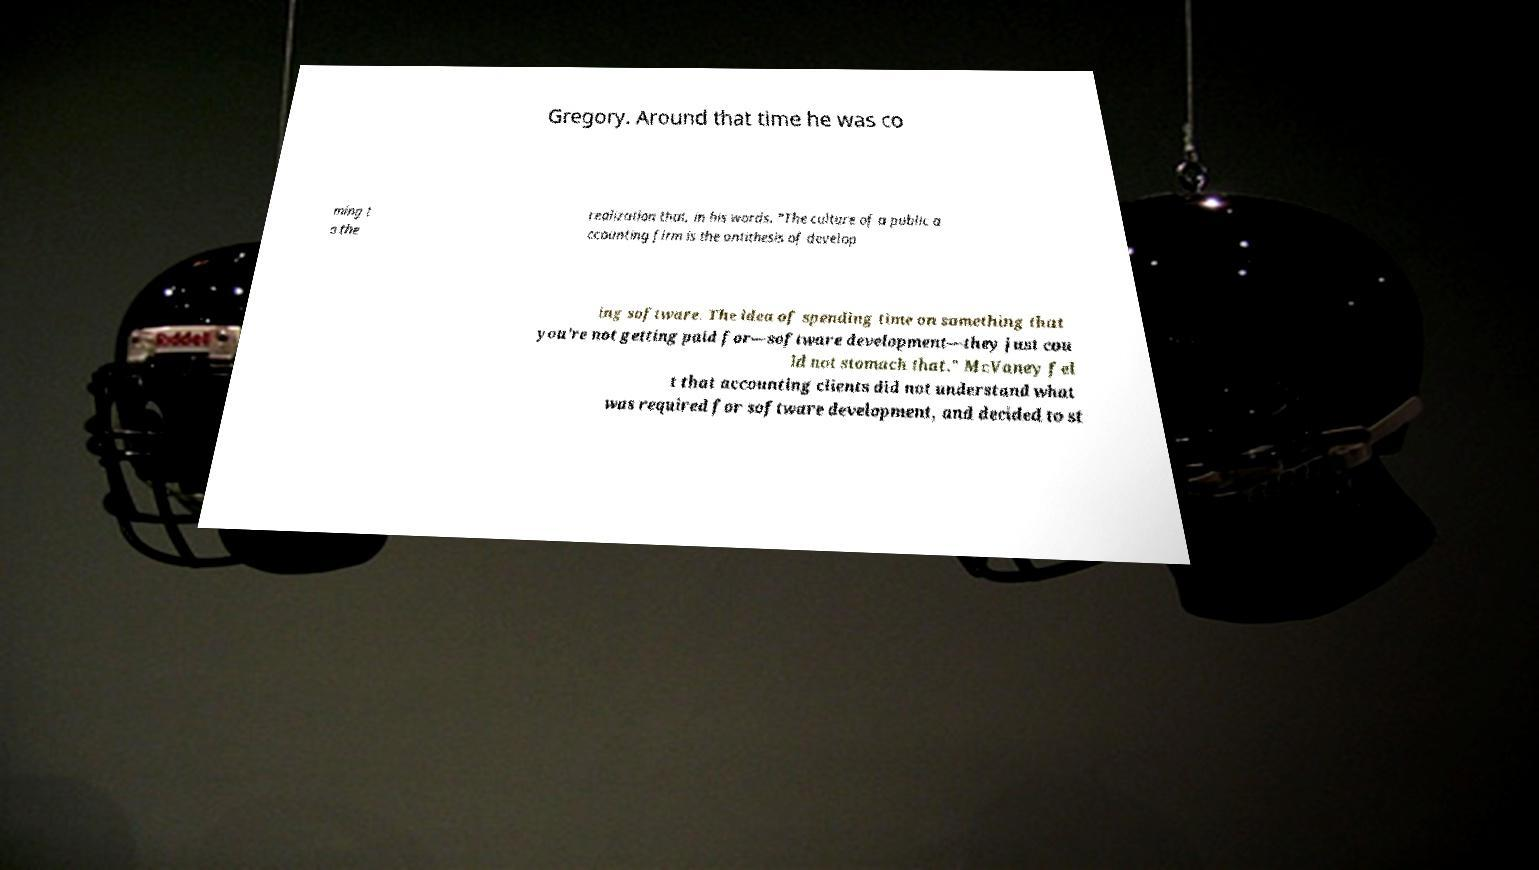Could you assist in decoding the text presented in this image and type it out clearly? Gregory. Around that time he was co ming t o the realization that, in his words, "The culture of a public a ccounting firm is the antithesis of develop ing software. The idea of spending time on something that you’re not getting paid for—software development—they just cou ld not stomach that." McVaney fel t that accounting clients did not understand what was required for software development, and decided to st 